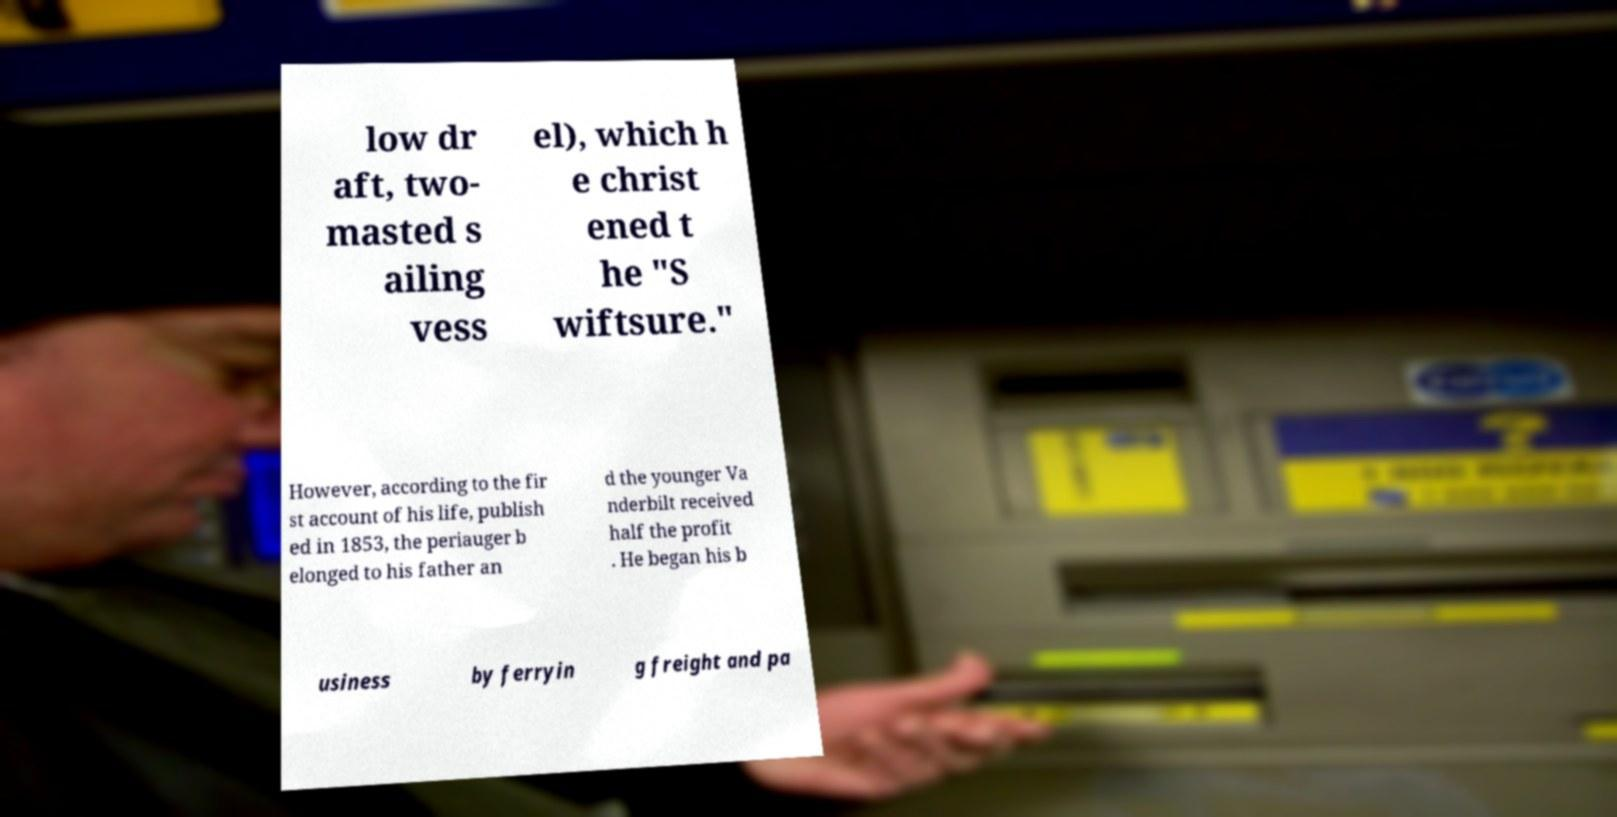Can you accurately transcribe the text from the provided image for me? low dr aft, two- masted s ailing vess el), which h e christ ened t he "S wiftsure." However, according to the fir st account of his life, publish ed in 1853, the periauger b elonged to his father an d the younger Va nderbilt received half the profit . He began his b usiness by ferryin g freight and pa 